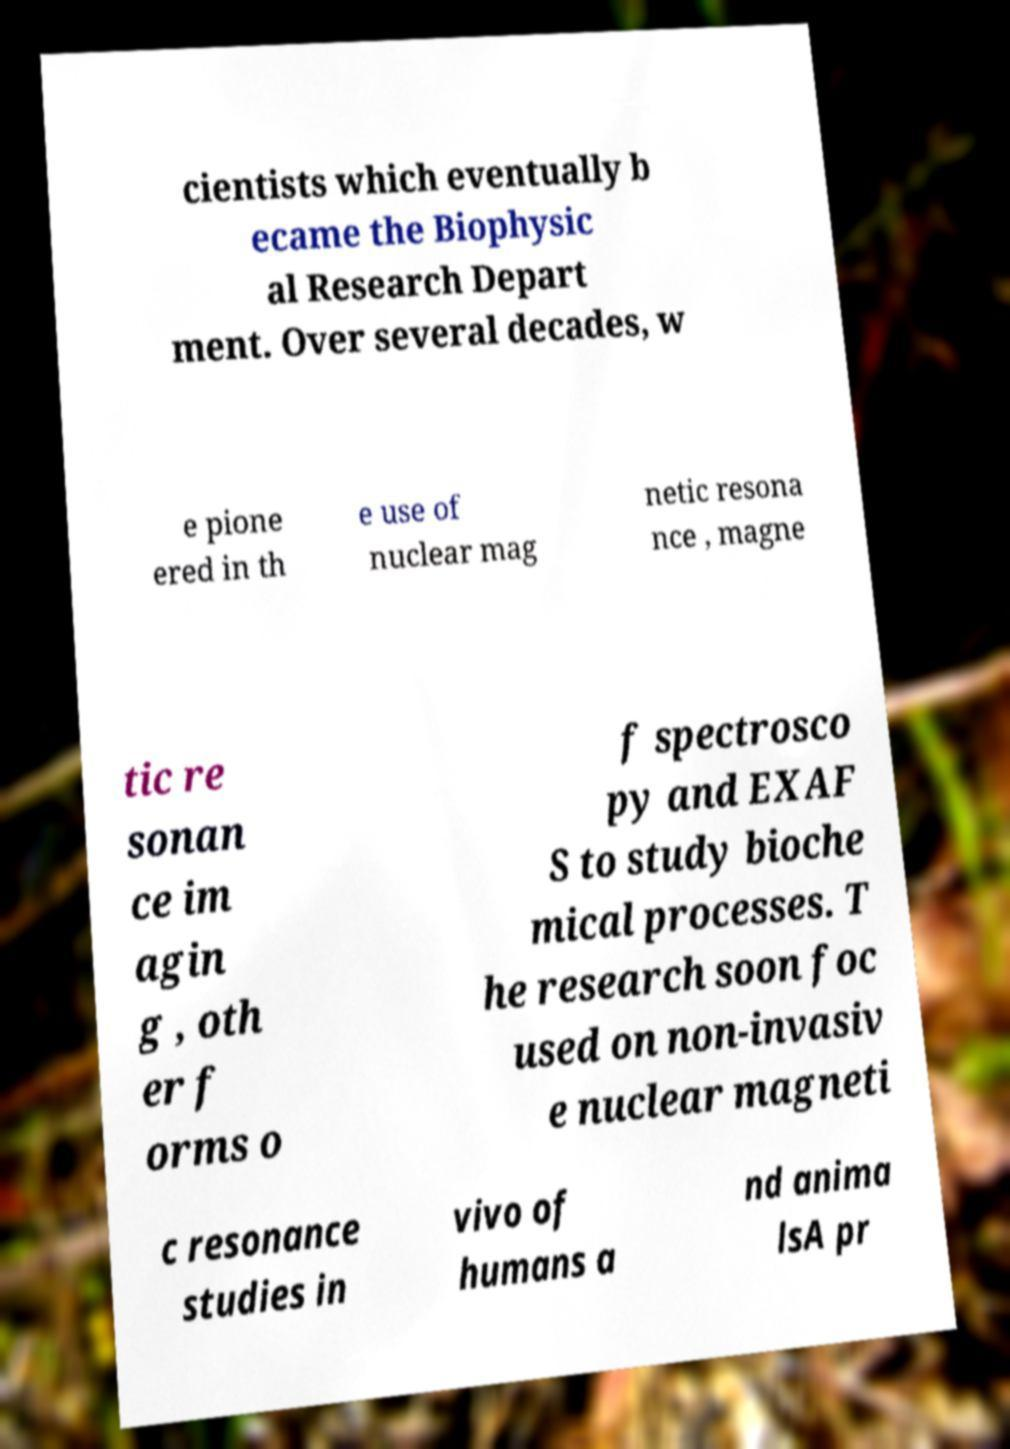Could you extract and type out the text from this image? cientists which eventually b ecame the Biophysic al Research Depart ment. Over several decades, w e pione ered in th e use of nuclear mag netic resona nce , magne tic re sonan ce im agin g , oth er f orms o f spectrosco py and EXAF S to study bioche mical processes. T he research soon foc used on non-invasiv e nuclear magneti c resonance studies in vivo of humans a nd anima lsA pr 